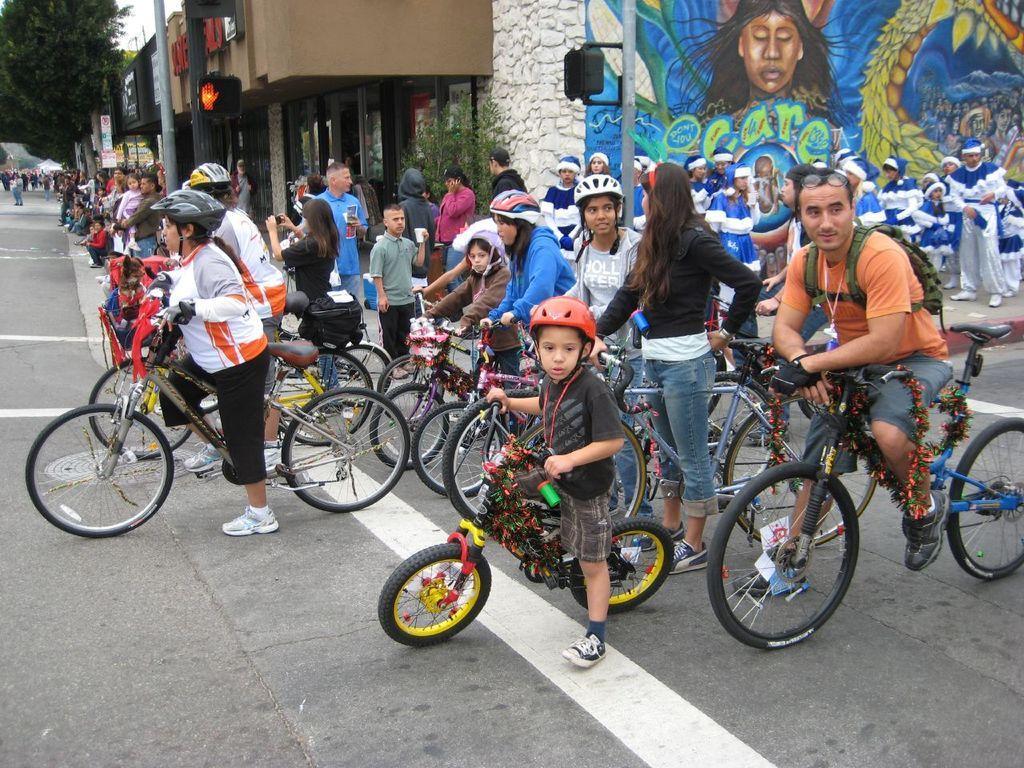Can you describe this image briefly? We can able to see a person sitting on a bicycles and wore helmet. These persons are standing. This is a building. On this wall there is a painting. Far there are numbers of trees. 